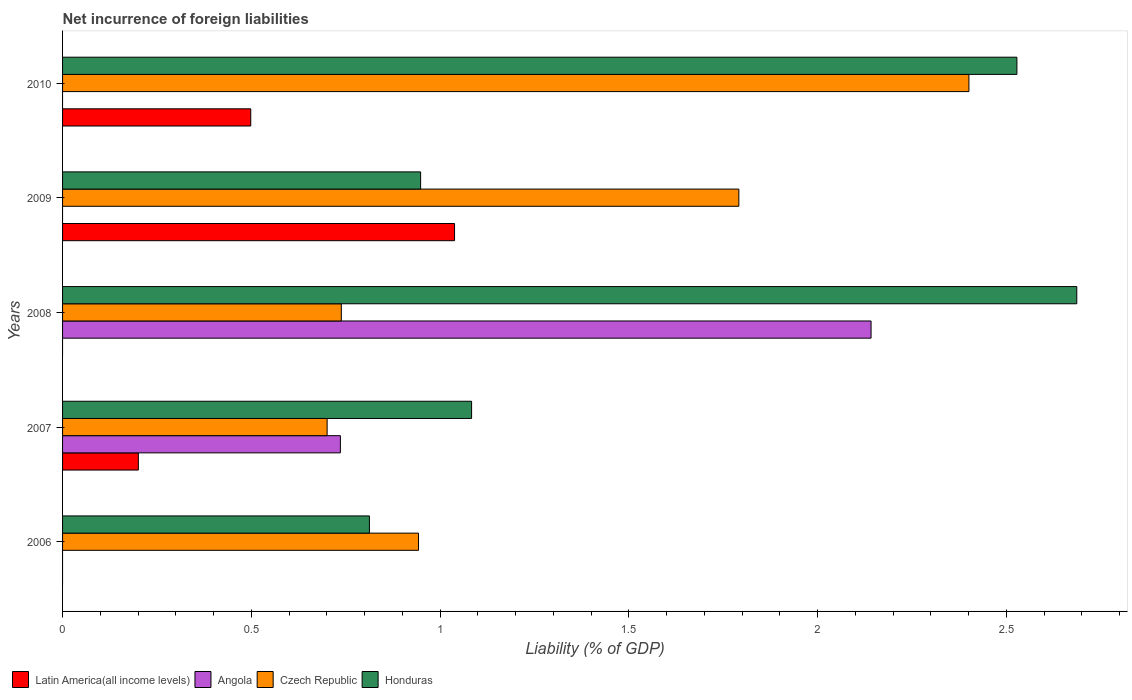How many groups of bars are there?
Give a very brief answer. 5. Are the number of bars on each tick of the Y-axis equal?
Provide a short and direct response. No. How many bars are there on the 3rd tick from the top?
Your response must be concise. 3. How many bars are there on the 5th tick from the bottom?
Give a very brief answer. 3. In how many cases, is the number of bars for a given year not equal to the number of legend labels?
Give a very brief answer. 4. What is the net incurrence of foreign liabilities in Latin America(all income levels) in 2006?
Provide a succinct answer. 0. Across all years, what is the maximum net incurrence of foreign liabilities in Latin America(all income levels)?
Provide a succinct answer. 1.04. In which year was the net incurrence of foreign liabilities in Latin America(all income levels) maximum?
Your response must be concise. 2009. What is the total net incurrence of foreign liabilities in Latin America(all income levels) in the graph?
Give a very brief answer. 1.74. What is the difference between the net incurrence of foreign liabilities in Honduras in 2008 and that in 2010?
Your answer should be very brief. 0.16. What is the difference between the net incurrence of foreign liabilities in Angola in 2010 and the net incurrence of foreign liabilities in Honduras in 2007?
Provide a short and direct response. -1.08. What is the average net incurrence of foreign liabilities in Honduras per year?
Your answer should be very brief. 1.61. In the year 2008, what is the difference between the net incurrence of foreign liabilities in Czech Republic and net incurrence of foreign liabilities in Honduras?
Your answer should be compact. -1.95. What is the ratio of the net incurrence of foreign liabilities in Honduras in 2008 to that in 2010?
Your answer should be very brief. 1.06. Is the net incurrence of foreign liabilities in Czech Republic in 2007 less than that in 2008?
Make the answer very short. Yes. Is the difference between the net incurrence of foreign liabilities in Czech Republic in 2009 and 2010 greater than the difference between the net incurrence of foreign liabilities in Honduras in 2009 and 2010?
Your response must be concise. Yes. What is the difference between the highest and the second highest net incurrence of foreign liabilities in Latin America(all income levels)?
Your response must be concise. 0.54. What is the difference between the highest and the lowest net incurrence of foreign liabilities in Honduras?
Provide a short and direct response. 1.87. Is the sum of the net incurrence of foreign liabilities in Honduras in 2006 and 2007 greater than the maximum net incurrence of foreign liabilities in Angola across all years?
Your answer should be very brief. No. Is it the case that in every year, the sum of the net incurrence of foreign liabilities in Czech Republic and net incurrence of foreign liabilities in Honduras is greater than the sum of net incurrence of foreign liabilities in Angola and net incurrence of foreign liabilities in Latin America(all income levels)?
Give a very brief answer. No. Are all the bars in the graph horizontal?
Provide a short and direct response. Yes. How many years are there in the graph?
Your response must be concise. 5. What is the difference between two consecutive major ticks on the X-axis?
Give a very brief answer. 0.5. How many legend labels are there?
Provide a succinct answer. 4. How are the legend labels stacked?
Make the answer very short. Horizontal. What is the title of the graph?
Ensure brevity in your answer.  Net incurrence of foreign liabilities. Does "Latin America(developing only)" appear as one of the legend labels in the graph?
Your answer should be very brief. No. What is the label or title of the X-axis?
Your response must be concise. Liability (% of GDP). What is the Liability (% of GDP) of Latin America(all income levels) in 2006?
Offer a very short reply. 0. What is the Liability (% of GDP) in Angola in 2006?
Offer a terse response. 0. What is the Liability (% of GDP) of Czech Republic in 2006?
Your answer should be compact. 0.94. What is the Liability (% of GDP) in Honduras in 2006?
Offer a very short reply. 0.81. What is the Liability (% of GDP) of Latin America(all income levels) in 2007?
Make the answer very short. 0.2. What is the Liability (% of GDP) of Angola in 2007?
Offer a terse response. 0.74. What is the Liability (% of GDP) in Czech Republic in 2007?
Ensure brevity in your answer.  0.7. What is the Liability (% of GDP) in Honduras in 2007?
Provide a succinct answer. 1.08. What is the Liability (% of GDP) of Latin America(all income levels) in 2008?
Offer a terse response. 0. What is the Liability (% of GDP) in Angola in 2008?
Keep it short and to the point. 2.14. What is the Liability (% of GDP) of Czech Republic in 2008?
Your response must be concise. 0.74. What is the Liability (% of GDP) of Honduras in 2008?
Keep it short and to the point. 2.69. What is the Liability (% of GDP) of Latin America(all income levels) in 2009?
Ensure brevity in your answer.  1.04. What is the Liability (% of GDP) of Czech Republic in 2009?
Your answer should be very brief. 1.79. What is the Liability (% of GDP) of Honduras in 2009?
Give a very brief answer. 0.95. What is the Liability (% of GDP) of Latin America(all income levels) in 2010?
Offer a terse response. 0.5. What is the Liability (% of GDP) of Czech Republic in 2010?
Provide a short and direct response. 2.4. What is the Liability (% of GDP) of Honduras in 2010?
Offer a very short reply. 2.53. Across all years, what is the maximum Liability (% of GDP) in Latin America(all income levels)?
Give a very brief answer. 1.04. Across all years, what is the maximum Liability (% of GDP) of Angola?
Make the answer very short. 2.14. Across all years, what is the maximum Liability (% of GDP) of Czech Republic?
Your answer should be very brief. 2.4. Across all years, what is the maximum Liability (% of GDP) of Honduras?
Offer a very short reply. 2.69. Across all years, what is the minimum Liability (% of GDP) in Latin America(all income levels)?
Keep it short and to the point. 0. Across all years, what is the minimum Liability (% of GDP) of Angola?
Provide a short and direct response. 0. Across all years, what is the minimum Liability (% of GDP) in Czech Republic?
Your answer should be very brief. 0.7. Across all years, what is the minimum Liability (% of GDP) in Honduras?
Offer a terse response. 0.81. What is the total Liability (% of GDP) of Latin America(all income levels) in the graph?
Offer a terse response. 1.74. What is the total Liability (% of GDP) in Angola in the graph?
Your answer should be compact. 2.88. What is the total Liability (% of GDP) in Czech Republic in the graph?
Your response must be concise. 6.57. What is the total Liability (% of GDP) in Honduras in the graph?
Give a very brief answer. 8.06. What is the difference between the Liability (% of GDP) in Czech Republic in 2006 and that in 2007?
Provide a succinct answer. 0.24. What is the difference between the Liability (% of GDP) of Honduras in 2006 and that in 2007?
Give a very brief answer. -0.27. What is the difference between the Liability (% of GDP) in Czech Republic in 2006 and that in 2008?
Your response must be concise. 0.2. What is the difference between the Liability (% of GDP) in Honduras in 2006 and that in 2008?
Provide a succinct answer. -1.87. What is the difference between the Liability (% of GDP) of Czech Republic in 2006 and that in 2009?
Offer a very short reply. -0.85. What is the difference between the Liability (% of GDP) of Honduras in 2006 and that in 2009?
Make the answer very short. -0.14. What is the difference between the Liability (% of GDP) in Czech Republic in 2006 and that in 2010?
Make the answer very short. -1.46. What is the difference between the Liability (% of GDP) of Honduras in 2006 and that in 2010?
Your answer should be compact. -1.72. What is the difference between the Liability (% of GDP) of Angola in 2007 and that in 2008?
Provide a short and direct response. -1.41. What is the difference between the Liability (% of GDP) in Czech Republic in 2007 and that in 2008?
Ensure brevity in your answer.  -0.04. What is the difference between the Liability (% of GDP) of Honduras in 2007 and that in 2008?
Make the answer very short. -1.6. What is the difference between the Liability (% of GDP) of Latin America(all income levels) in 2007 and that in 2009?
Provide a short and direct response. -0.84. What is the difference between the Liability (% of GDP) of Czech Republic in 2007 and that in 2009?
Offer a terse response. -1.09. What is the difference between the Liability (% of GDP) in Honduras in 2007 and that in 2009?
Offer a terse response. 0.14. What is the difference between the Liability (% of GDP) of Latin America(all income levels) in 2007 and that in 2010?
Your answer should be very brief. -0.3. What is the difference between the Liability (% of GDP) of Czech Republic in 2007 and that in 2010?
Your answer should be compact. -1.7. What is the difference between the Liability (% of GDP) in Honduras in 2007 and that in 2010?
Your response must be concise. -1.44. What is the difference between the Liability (% of GDP) of Czech Republic in 2008 and that in 2009?
Your answer should be very brief. -1.05. What is the difference between the Liability (% of GDP) in Honduras in 2008 and that in 2009?
Keep it short and to the point. 1.74. What is the difference between the Liability (% of GDP) in Czech Republic in 2008 and that in 2010?
Your answer should be very brief. -1.66. What is the difference between the Liability (% of GDP) of Honduras in 2008 and that in 2010?
Keep it short and to the point. 0.16. What is the difference between the Liability (% of GDP) in Latin America(all income levels) in 2009 and that in 2010?
Your answer should be very brief. 0.54. What is the difference between the Liability (% of GDP) in Czech Republic in 2009 and that in 2010?
Offer a terse response. -0.61. What is the difference between the Liability (% of GDP) in Honduras in 2009 and that in 2010?
Offer a terse response. -1.58. What is the difference between the Liability (% of GDP) in Czech Republic in 2006 and the Liability (% of GDP) in Honduras in 2007?
Your response must be concise. -0.14. What is the difference between the Liability (% of GDP) of Czech Republic in 2006 and the Liability (% of GDP) of Honduras in 2008?
Your answer should be compact. -1.74. What is the difference between the Liability (% of GDP) of Czech Republic in 2006 and the Liability (% of GDP) of Honduras in 2009?
Provide a short and direct response. -0.01. What is the difference between the Liability (% of GDP) in Czech Republic in 2006 and the Liability (% of GDP) in Honduras in 2010?
Keep it short and to the point. -1.59. What is the difference between the Liability (% of GDP) of Latin America(all income levels) in 2007 and the Liability (% of GDP) of Angola in 2008?
Provide a short and direct response. -1.94. What is the difference between the Liability (% of GDP) of Latin America(all income levels) in 2007 and the Liability (% of GDP) of Czech Republic in 2008?
Your response must be concise. -0.54. What is the difference between the Liability (% of GDP) of Latin America(all income levels) in 2007 and the Liability (% of GDP) of Honduras in 2008?
Your answer should be compact. -2.49. What is the difference between the Liability (% of GDP) in Angola in 2007 and the Liability (% of GDP) in Czech Republic in 2008?
Your answer should be compact. -0. What is the difference between the Liability (% of GDP) in Angola in 2007 and the Liability (% of GDP) in Honduras in 2008?
Your answer should be compact. -1.95. What is the difference between the Liability (% of GDP) in Czech Republic in 2007 and the Liability (% of GDP) in Honduras in 2008?
Your answer should be compact. -1.99. What is the difference between the Liability (% of GDP) of Latin America(all income levels) in 2007 and the Liability (% of GDP) of Czech Republic in 2009?
Ensure brevity in your answer.  -1.59. What is the difference between the Liability (% of GDP) in Latin America(all income levels) in 2007 and the Liability (% of GDP) in Honduras in 2009?
Your answer should be compact. -0.75. What is the difference between the Liability (% of GDP) in Angola in 2007 and the Liability (% of GDP) in Czech Republic in 2009?
Your answer should be compact. -1.06. What is the difference between the Liability (% of GDP) in Angola in 2007 and the Liability (% of GDP) in Honduras in 2009?
Your response must be concise. -0.21. What is the difference between the Liability (% of GDP) of Czech Republic in 2007 and the Liability (% of GDP) of Honduras in 2009?
Your answer should be very brief. -0.25. What is the difference between the Liability (% of GDP) in Latin America(all income levels) in 2007 and the Liability (% of GDP) in Czech Republic in 2010?
Keep it short and to the point. -2.2. What is the difference between the Liability (% of GDP) of Latin America(all income levels) in 2007 and the Liability (% of GDP) of Honduras in 2010?
Offer a terse response. -2.33. What is the difference between the Liability (% of GDP) of Angola in 2007 and the Liability (% of GDP) of Czech Republic in 2010?
Your answer should be very brief. -1.66. What is the difference between the Liability (% of GDP) in Angola in 2007 and the Liability (% of GDP) in Honduras in 2010?
Make the answer very short. -1.79. What is the difference between the Liability (% of GDP) in Czech Republic in 2007 and the Liability (% of GDP) in Honduras in 2010?
Offer a very short reply. -1.83. What is the difference between the Liability (% of GDP) in Angola in 2008 and the Liability (% of GDP) in Czech Republic in 2009?
Ensure brevity in your answer.  0.35. What is the difference between the Liability (% of GDP) of Angola in 2008 and the Liability (% of GDP) of Honduras in 2009?
Give a very brief answer. 1.19. What is the difference between the Liability (% of GDP) in Czech Republic in 2008 and the Liability (% of GDP) in Honduras in 2009?
Provide a short and direct response. -0.21. What is the difference between the Liability (% of GDP) in Angola in 2008 and the Liability (% of GDP) in Czech Republic in 2010?
Your response must be concise. -0.26. What is the difference between the Liability (% of GDP) of Angola in 2008 and the Liability (% of GDP) of Honduras in 2010?
Offer a terse response. -0.39. What is the difference between the Liability (% of GDP) in Czech Republic in 2008 and the Liability (% of GDP) in Honduras in 2010?
Keep it short and to the point. -1.79. What is the difference between the Liability (% of GDP) of Latin America(all income levels) in 2009 and the Liability (% of GDP) of Czech Republic in 2010?
Ensure brevity in your answer.  -1.36. What is the difference between the Liability (% of GDP) of Latin America(all income levels) in 2009 and the Liability (% of GDP) of Honduras in 2010?
Ensure brevity in your answer.  -1.49. What is the difference between the Liability (% of GDP) of Czech Republic in 2009 and the Liability (% of GDP) of Honduras in 2010?
Your response must be concise. -0.74. What is the average Liability (% of GDP) of Latin America(all income levels) per year?
Provide a succinct answer. 0.35. What is the average Liability (% of GDP) of Angola per year?
Keep it short and to the point. 0.58. What is the average Liability (% of GDP) in Czech Republic per year?
Provide a succinct answer. 1.31. What is the average Liability (% of GDP) of Honduras per year?
Offer a very short reply. 1.61. In the year 2006, what is the difference between the Liability (% of GDP) in Czech Republic and Liability (% of GDP) in Honduras?
Your answer should be compact. 0.13. In the year 2007, what is the difference between the Liability (% of GDP) in Latin America(all income levels) and Liability (% of GDP) in Angola?
Offer a very short reply. -0.54. In the year 2007, what is the difference between the Liability (% of GDP) of Latin America(all income levels) and Liability (% of GDP) of Czech Republic?
Your response must be concise. -0.5. In the year 2007, what is the difference between the Liability (% of GDP) of Latin America(all income levels) and Liability (% of GDP) of Honduras?
Make the answer very short. -0.88. In the year 2007, what is the difference between the Liability (% of GDP) of Angola and Liability (% of GDP) of Czech Republic?
Provide a short and direct response. 0.04. In the year 2007, what is the difference between the Liability (% of GDP) in Angola and Liability (% of GDP) in Honduras?
Provide a short and direct response. -0.35. In the year 2007, what is the difference between the Liability (% of GDP) in Czech Republic and Liability (% of GDP) in Honduras?
Keep it short and to the point. -0.38. In the year 2008, what is the difference between the Liability (% of GDP) in Angola and Liability (% of GDP) in Czech Republic?
Make the answer very short. 1.4. In the year 2008, what is the difference between the Liability (% of GDP) in Angola and Liability (% of GDP) in Honduras?
Offer a very short reply. -0.54. In the year 2008, what is the difference between the Liability (% of GDP) in Czech Republic and Liability (% of GDP) in Honduras?
Your answer should be compact. -1.95. In the year 2009, what is the difference between the Liability (% of GDP) of Latin America(all income levels) and Liability (% of GDP) of Czech Republic?
Keep it short and to the point. -0.75. In the year 2009, what is the difference between the Liability (% of GDP) of Latin America(all income levels) and Liability (% of GDP) of Honduras?
Offer a very short reply. 0.09. In the year 2009, what is the difference between the Liability (% of GDP) of Czech Republic and Liability (% of GDP) of Honduras?
Make the answer very short. 0.84. In the year 2010, what is the difference between the Liability (% of GDP) of Latin America(all income levels) and Liability (% of GDP) of Czech Republic?
Provide a succinct answer. -1.9. In the year 2010, what is the difference between the Liability (% of GDP) in Latin America(all income levels) and Liability (% of GDP) in Honduras?
Offer a very short reply. -2.03. In the year 2010, what is the difference between the Liability (% of GDP) in Czech Republic and Liability (% of GDP) in Honduras?
Offer a very short reply. -0.13. What is the ratio of the Liability (% of GDP) of Czech Republic in 2006 to that in 2007?
Make the answer very short. 1.35. What is the ratio of the Liability (% of GDP) of Honduras in 2006 to that in 2007?
Your answer should be compact. 0.75. What is the ratio of the Liability (% of GDP) in Czech Republic in 2006 to that in 2008?
Provide a succinct answer. 1.28. What is the ratio of the Liability (% of GDP) of Honduras in 2006 to that in 2008?
Give a very brief answer. 0.3. What is the ratio of the Liability (% of GDP) in Czech Republic in 2006 to that in 2009?
Your response must be concise. 0.53. What is the ratio of the Liability (% of GDP) of Honduras in 2006 to that in 2009?
Offer a terse response. 0.86. What is the ratio of the Liability (% of GDP) in Czech Republic in 2006 to that in 2010?
Ensure brevity in your answer.  0.39. What is the ratio of the Liability (% of GDP) in Honduras in 2006 to that in 2010?
Your answer should be compact. 0.32. What is the ratio of the Liability (% of GDP) of Angola in 2007 to that in 2008?
Offer a very short reply. 0.34. What is the ratio of the Liability (% of GDP) in Czech Republic in 2007 to that in 2008?
Give a very brief answer. 0.95. What is the ratio of the Liability (% of GDP) in Honduras in 2007 to that in 2008?
Offer a very short reply. 0.4. What is the ratio of the Liability (% of GDP) in Latin America(all income levels) in 2007 to that in 2009?
Your answer should be compact. 0.19. What is the ratio of the Liability (% of GDP) in Czech Republic in 2007 to that in 2009?
Provide a succinct answer. 0.39. What is the ratio of the Liability (% of GDP) of Honduras in 2007 to that in 2009?
Ensure brevity in your answer.  1.14. What is the ratio of the Liability (% of GDP) of Latin America(all income levels) in 2007 to that in 2010?
Make the answer very short. 0.4. What is the ratio of the Liability (% of GDP) of Czech Republic in 2007 to that in 2010?
Make the answer very short. 0.29. What is the ratio of the Liability (% of GDP) of Honduras in 2007 to that in 2010?
Keep it short and to the point. 0.43. What is the ratio of the Liability (% of GDP) of Czech Republic in 2008 to that in 2009?
Offer a very short reply. 0.41. What is the ratio of the Liability (% of GDP) of Honduras in 2008 to that in 2009?
Provide a short and direct response. 2.83. What is the ratio of the Liability (% of GDP) in Czech Republic in 2008 to that in 2010?
Keep it short and to the point. 0.31. What is the ratio of the Liability (% of GDP) in Honduras in 2008 to that in 2010?
Keep it short and to the point. 1.06. What is the ratio of the Liability (% of GDP) in Latin America(all income levels) in 2009 to that in 2010?
Provide a short and direct response. 2.08. What is the ratio of the Liability (% of GDP) in Czech Republic in 2009 to that in 2010?
Your answer should be compact. 0.75. What is the ratio of the Liability (% of GDP) in Honduras in 2009 to that in 2010?
Provide a succinct answer. 0.38. What is the difference between the highest and the second highest Liability (% of GDP) in Latin America(all income levels)?
Offer a terse response. 0.54. What is the difference between the highest and the second highest Liability (% of GDP) in Czech Republic?
Provide a short and direct response. 0.61. What is the difference between the highest and the second highest Liability (% of GDP) in Honduras?
Offer a very short reply. 0.16. What is the difference between the highest and the lowest Liability (% of GDP) of Latin America(all income levels)?
Give a very brief answer. 1.04. What is the difference between the highest and the lowest Liability (% of GDP) in Angola?
Your answer should be very brief. 2.14. What is the difference between the highest and the lowest Liability (% of GDP) of Czech Republic?
Make the answer very short. 1.7. What is the difference between the highest and the lowest Liability (% of GDP) of Honduras?
Give a very brief answer. 1.87. 